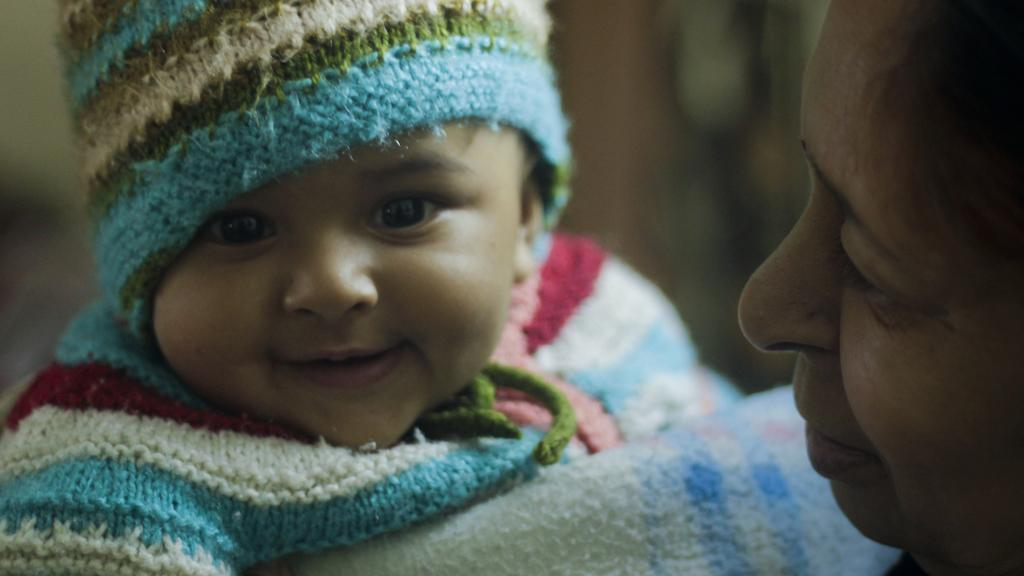Who is the main subject in the image? There is a woman in the image. What is the woman doing in the image? The woman is holding a baby. How does the baby appear in the image? The baby is smiling. Can you describe the background of the image? The background of the image is blurred. What arithmetic problem is the baby solving in the image? There is no arithmetic problem present in the image; the baby is simply smiling while being held by the woman. What type of pen is the woman using to write a note in the image? There is no pen or note-writing activity present in the image; the woman is holding a baby who is smiling. 